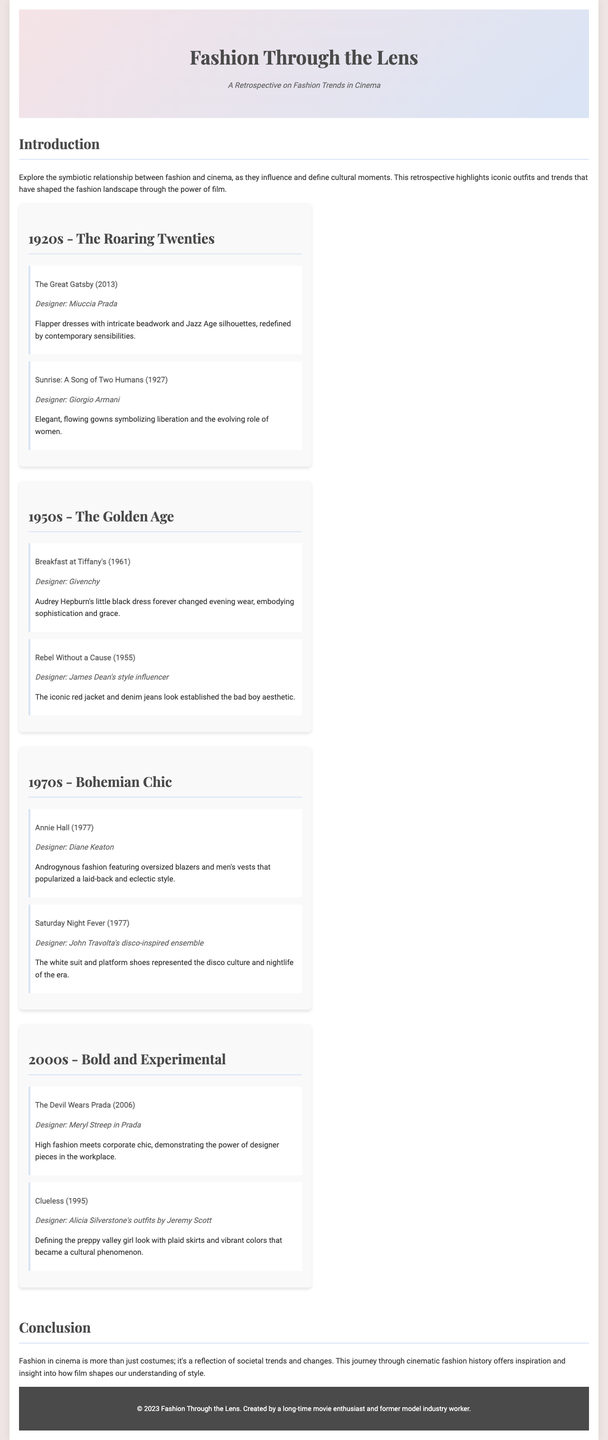what is the title of the brochure? The title is mentioned in the header section of the document, clearly indicating the focus on fashion and cinema.
Answer: Fashion Through the Lens who designed Audrey Hepburn's dress in Breakfast at Tiffany's? The designer's name for the film's iconic outfit is specified in the highlights of the 1950s section.
Answer: Givenchy which film represents the 1920s fashion era? The highlight section under the 1920s provides the names of films that exemplify the fashion of that decade.
Answer: The Great Gatsby (2013) what is one keyword used to describe the 1970s fashion style? The era's fashion traits are outlined in the highlighted films and cubbies, with key descriptors used for that decade.
Answer: Bohemian Chic who is the designer highlighted for the 2000s section? This can be found in the highlights of the relevant decade within the designer mentions.
Answer: Meryl Streep in Prada what iconic clothing item does James Dean wear in Rebel Without a Cause? This detail is part of the description of highlights and iconic looks for that decade, mentioned under the 1950s section.
Answer: Red jacket what is the common theme of the document? The overarching theme is introduced in the beginning section and reiterated in the conclusion of the document.
Answer: Symbiotic relationship between fashion and cinema which era is associated with the film Clueless? The timeline sections categorize films by eras, helping identify the specific fashion decade for each film.
Answer: 2000s who is a designer noted for 1970s style in Annie Hall? The document highlights specific designers related to certain films in the era sections, including the 1970s.
Answer: Diane Keaton 